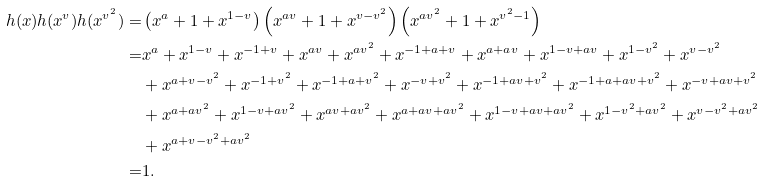Convert formula to latex. <formula><loc_0><loc_0><loc_500><loc_500>h ( x ) h ( x ^ { v } ) h ( x ^ { v ^ { 2 } } ) = & \left ( x ^ { a } + 1 + x ^ { 1 - v } \right ) \left ( x ^ { a v } + 1 + x ^ { v - v ^ { 2 } } \right ) \left ( x ^ { a v ^ { 2 } } + 1 + x ^ { v ^ { 2 } - 1 } \right ) \\ = & x ^ { a } + x ^ { 1 - v } + x ^ { - 1 + v } + x ^ { a v } + x ^ { a v ^ { 2 } } + x ^ { - 1 + a + v } + x ^ { a + a v } + x ^ { 1 - v + a v } + x ^ { 1 - v ^ { 2 } } + x ^ { v - v ^ { 2 } } \\ & + x ^ { a + v - v ^ { 2 } } + x ^ { - 1 + v ^ { 2 } } + x ^ { - 1 + a + v ^ { 2 } } + x ^ { - v + v ^ { 2 } } + x ^ { - 1 + a v + v ^ { 2 } } + x ^ { - 1 + a + a v + v ^ { 2 } } + x ^ { - v + a v + v ^ { 2 } } \\ & + x ^ { a + a v ^ { 2 } } + x ^ { 1 - v + a v ^ { 2 } } + x ^ { a v + a v ^ { 2 } } + x ^ { a + a v + a v ^ { 2 } } + x ^ { 1 - v + a v + a v ^ { 2 } } + x ^ { 1 - v ^ { 2 } + a v ^ { 2 } } + x ^ { v - v ^ { 2 } + a v ^ { 2 } } \\ & + x ^ { a + v - v ^ { 2 } + a v ^ { 2 } } \\ = & 1 . \\</formula> 